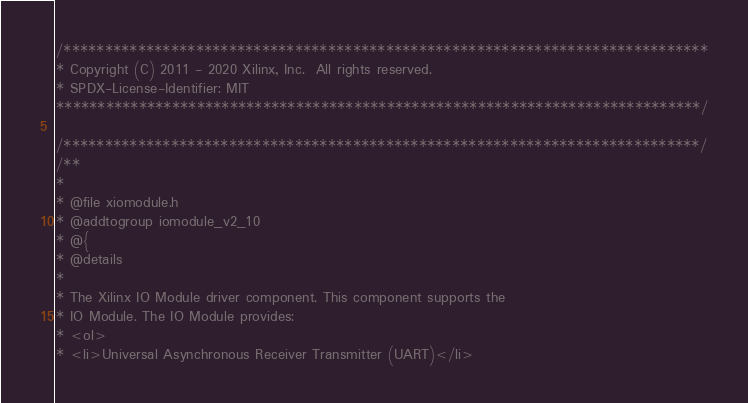<code> <loc_0><loc_0><loc_500><loc_500><_C_>/******************************************************************************
* Copyright (C) 2011 - 2020 Xilinx, Inc.  All rights reserved.
* SPDX-License-Identifier: MIT
******************************************************************************/

/*****************************************************************************/
/**
*
* @file xiomodule.h
* @addtogroup iomodule_v2_10
* @{
* @details
*
* The Xilinx IO Module driver component. This component supports the
* IO Module. The IO Module provides:
* <ol>
* <li>Universal Asynchronous Receiver Transmitter (UART)</li></code> 